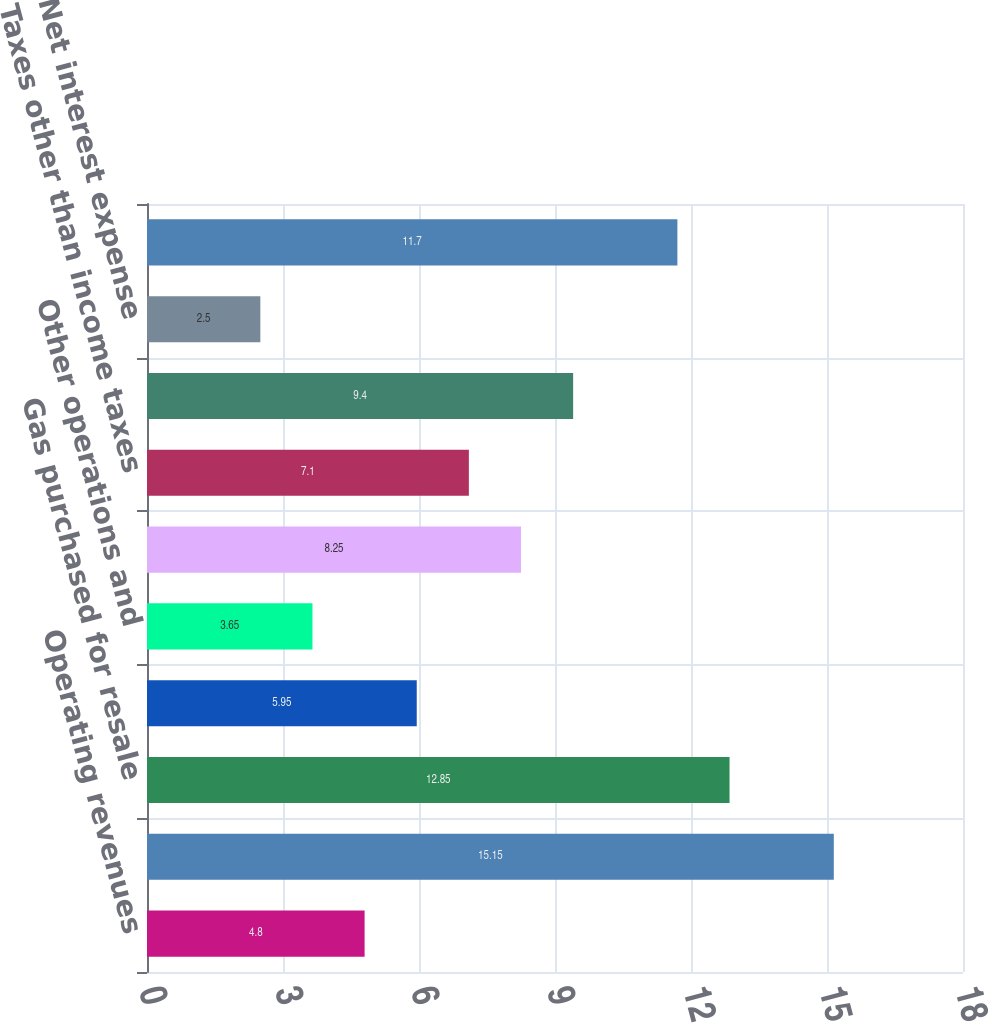Convert chart to OTSL. <chart><loc_0><loc_0><loc_500><loc_500><bar_chart><fcel>Operating revenues<fcel>Purchased power<fcel>Gas purchased for resale<fcel>Operating revenues less<fcel>Other operations and<fcel>Depreciation and amortization<fcel>Taxes other than income taxes<fcel>Operating income<fcel>Net interest expense<fcel>Income before income tax<nl><fcel>4.8<fcel>15.15<fcel>12.85<fcel>5.95<fcel>3.65<fcel>8.25<fcel>7.1<fcel>9.4<fcel>2.5<fcel>11.7<nl></chart> 